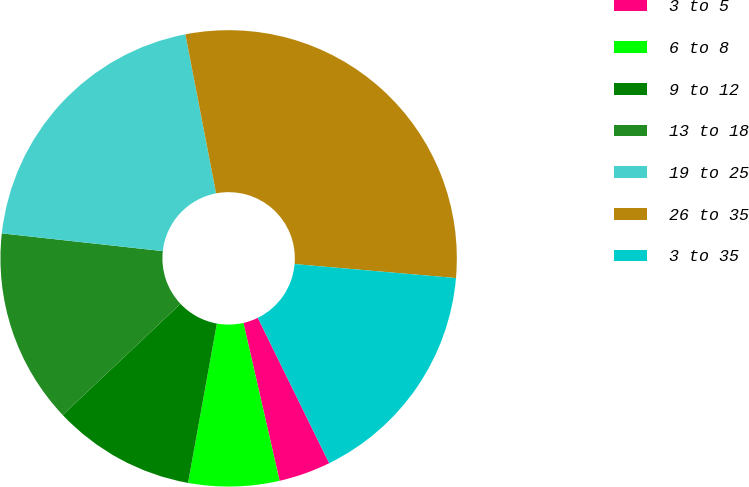Convert chart to OTSL. <chart><loc_0><loc_0><loc_500><loc_500><pie_chart><fcel>3 to 5<fcel>6 to 8<fcel>9 to 12<fcel>13 to 18<fcel>19 to 25<fcel>26 to 35<fcel>3 to 35<nl><fcel>3.68%<fcel>6.43%<fcel>10.11%<fcel>13.79%<fcel>20.22%<fcel>29.41%<fcel>16.36%<nl></chart> 